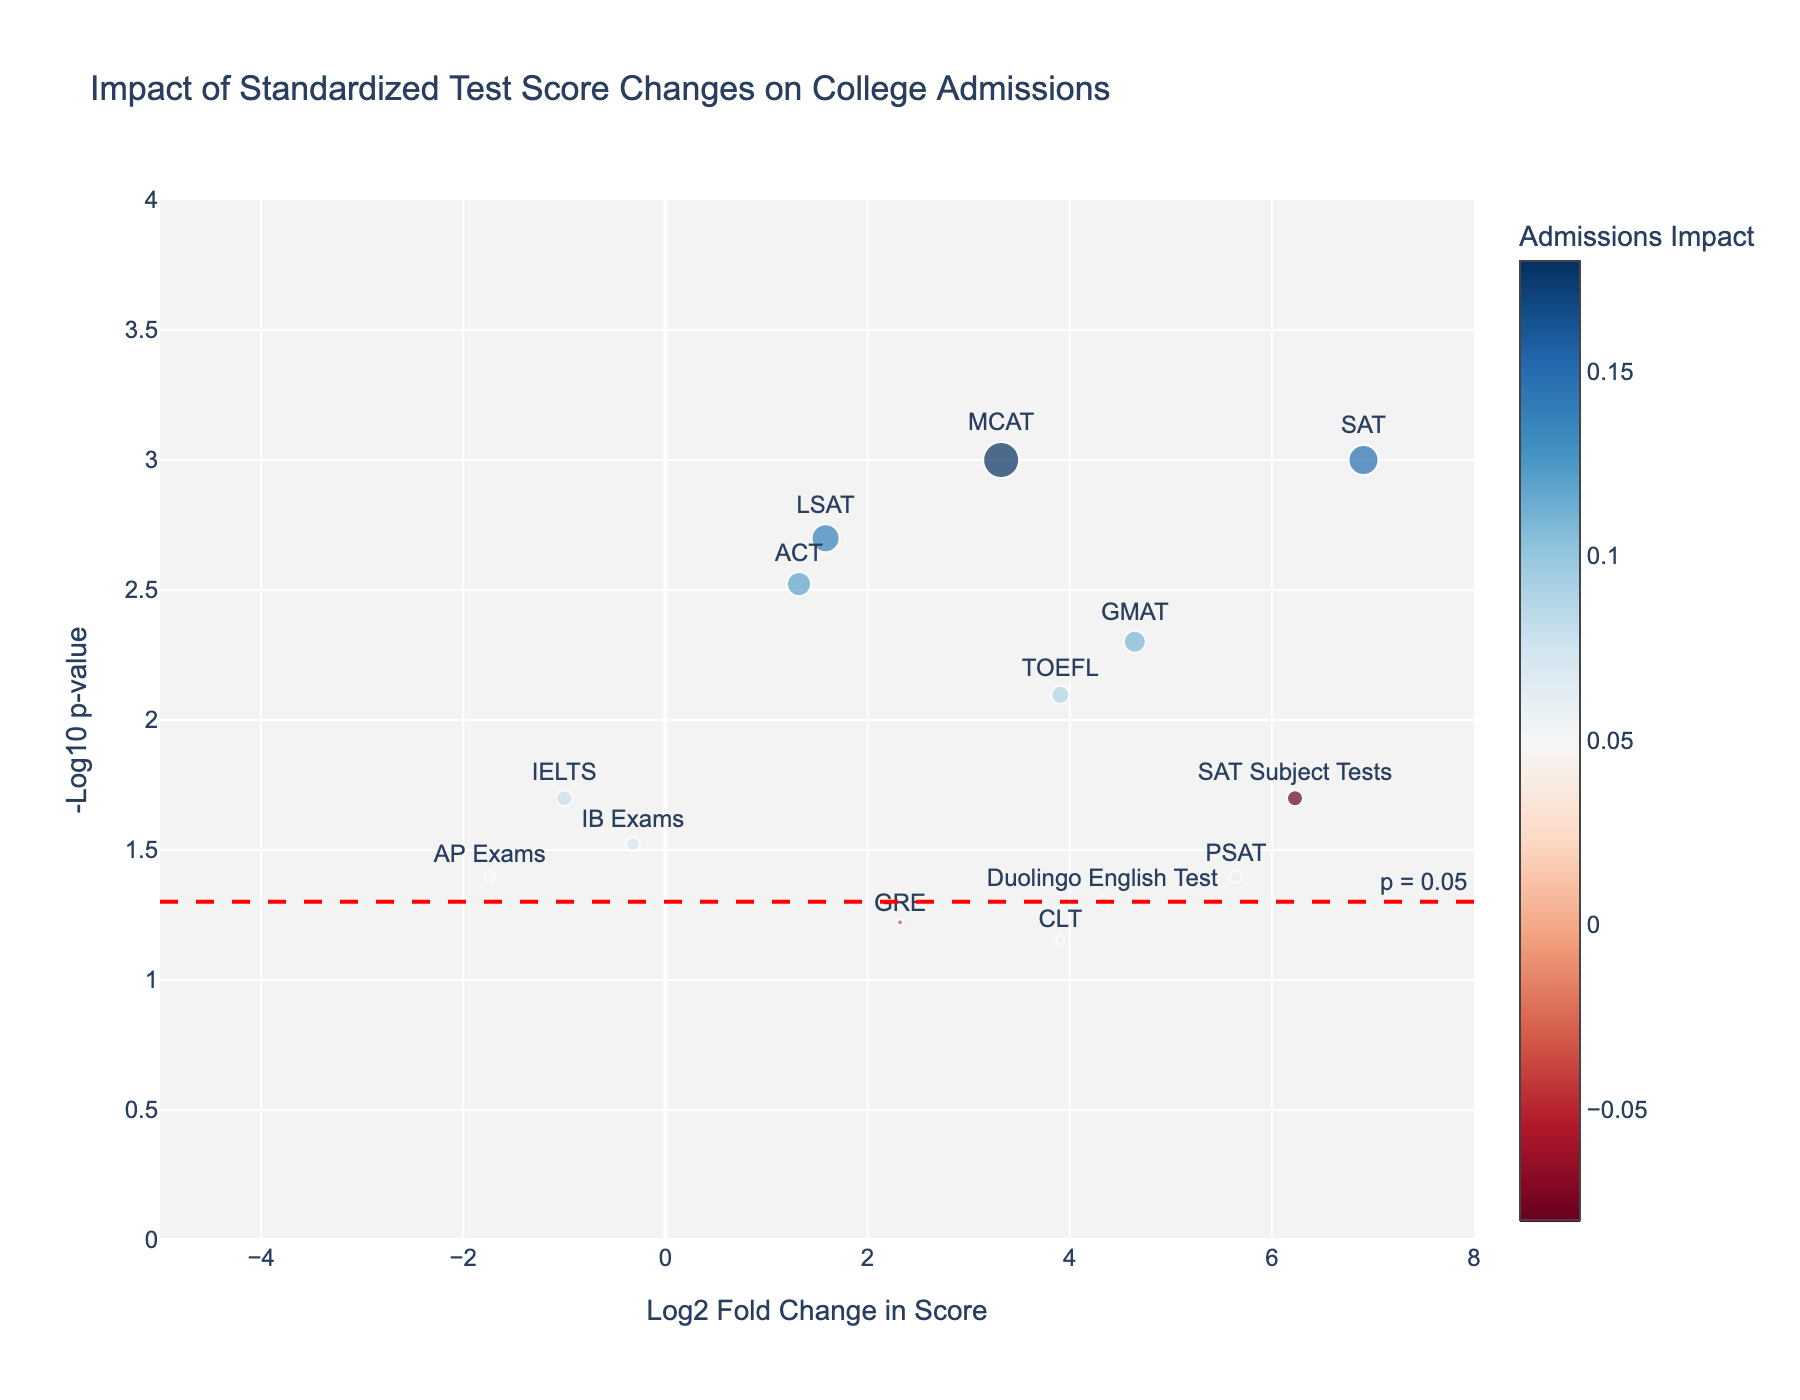What is the title of the figure? The title of the figure is typically displayed at the top of the plot. It is meant to give a concise description of what the plot represents.
Answer: "Impact of Standardized Test Score Changes on College Admissions" Which standardized test shows the highest admissions impact according to the plot? By looking at the size of the markers (indicating admissions impact), the MCAT shows the highest admissions impact since it has the largest marker in the plot.
Answer: MCAT What is the Log2 Fold Change of the SAT scores? Locate the marker labeled "SAT" and check its position along the x-axis, which represents Log2 Fold Change. The SAT is near a log2 fold change of around 6.
Answer: Approximately 6 How does the significance level of the ACT compare to that of the GRE? To compare significance levels, look at the y-axis values (-Log10 p-value) for both tests. The ACT has a higher -Log10 p-value (around 2.5) compared to the GRE, which has a -Log10 p-value closer to 1.2.
Answer: ACT has a higher significance level Which test shows a negative impact on admissions, and what is its Log2 Fold Change? Look for markers with negative color (typically blue). The SAT Subject Tests show a negative impact. Check its x-axis value for its log2 fold change, which is below zero (-6).
Answer: SAT Subject Tests, approximately -6 What does the red dashed line represent in the plot? The red dashed line is usually used to mark a significance threshold on a volcano plot. Here, it appears at -Log10 p-value = 1.3, corresponding to a p-value of 0.05.
Answer: p = 0.05 significance threshold Based on the text labels, how many different standardized tests are represented in the plot? Count the number of unique test names displayed as text labels on the markers. There are 14 different test names.
Answer: 14 Which test has the smallest Log2 Fold Change while still having a significant impact (p < 0.05)? First, identify tests with significant impacts (above the red dashed line). Then, find the marker closest to zero on the x-axis. The LSAT shows a log2 fold change close to 1.5 while being significantly impactful.
Answer: LSAT, approximately 1.5 What color represents a positive admissions impact in the plot? Examine the color scale of the markers. Typically, warmer colors (reds) indicate a positive impact, while cooler colors (blues) indicate a negative impact.
Answer: Red How does the log2 fold change of the Duolingo English Test compare to that of the AP Exams? Find and compare their positions on the x-axis. The Duolingo English Test has a higher log2 fold change (around 4.3) compared to the AP Exams (around -0.3).
Answer: Duolingo English Test has a higher log2 fold change 